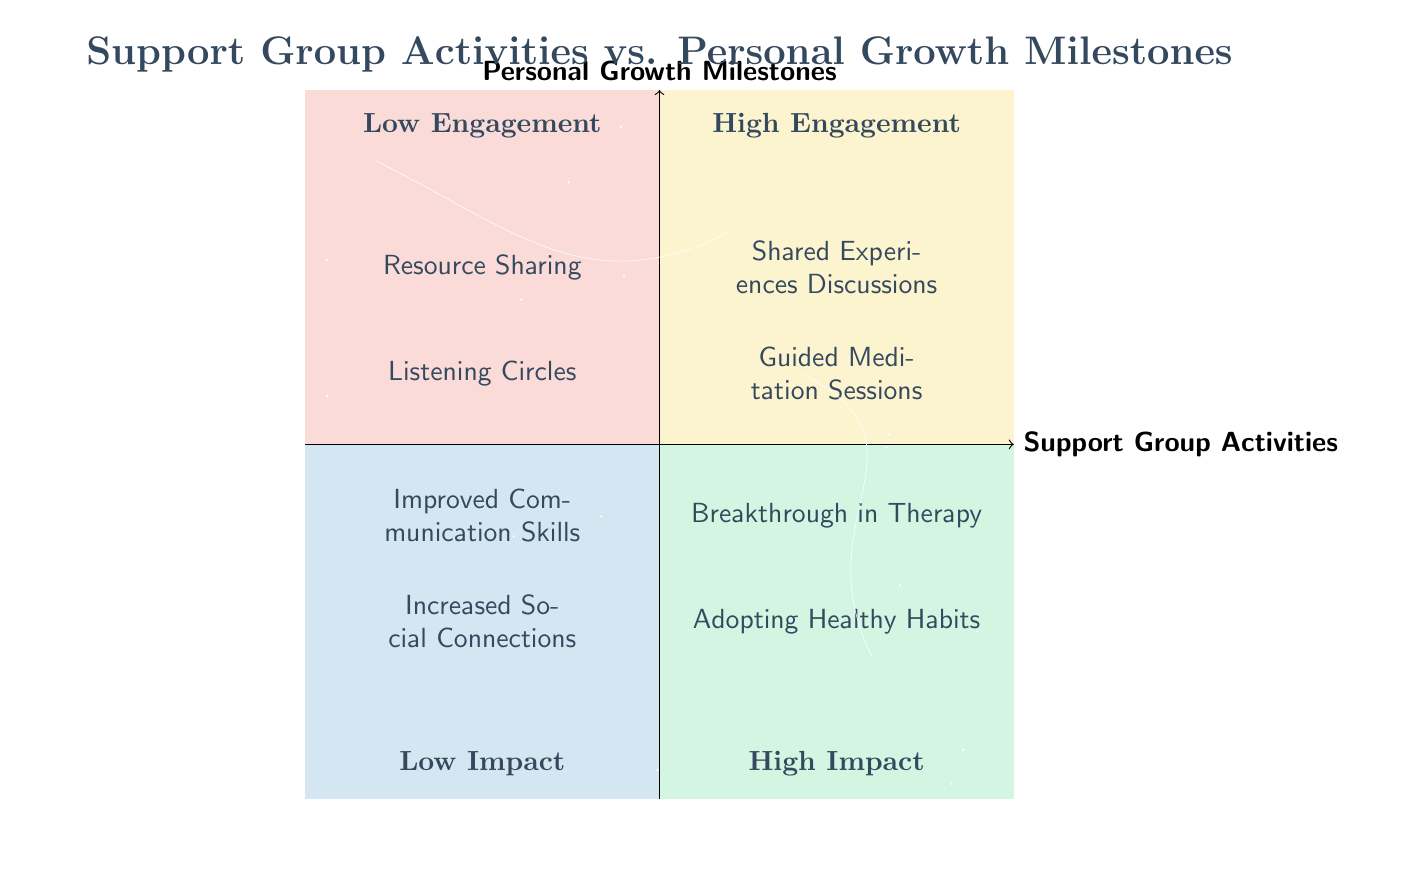What are the activities in the High Engagement quadrant? The High Engagement quadrant is found in the top right section of the diagram. In this section, there are two nodes, "Shared Experiences Discussions" and "Guided Meditation Sessions."
Answer: Shared Experiences Discussions, Guided Meditation Sessions Which Personal Growth Milestones are associated with Low Impact? The Low Impact section is located in the bottom left quadrant of the diagram. The two milestones listed there are "Improved Communication Skills" and "Increased Social Connections."
Answer: Improved Communication Skills, Increased Social Connections How many activities are categorized as Low Engagement? To find this, we look at the Low Engagement quadrant, which is in the bottom left portion of the diagram. There are two activities listed: "Resource Sharing" and "Listening Circles," which totals to two activities.
Answer: 2 What is the relationship between High Impact milestones and High Engagement activities? High Impact milestones, found in the top right quadrant, are "Breakthrough in Therapy" and "Adopting Healthy Habits." Both are associated with activities in the High Engagement quadrant. This suggests a positive correlation between engaging activities and significant personal growth outcomes.
Answer: Positive correlation Which activity is closest to the Low Impact milestones? In the diagram, the Low Impact milestones are located in the bottom left quadrant. The activity closest to this area, directly above it in the Low Engagement quadrant, is "Listening Circles."
Answer: Listening Circles How many nodes are in the Low Engagement quadrant? The Low Engagement quadrant contains two activities: "Resource Sharing" and "Listening Circles." By counting these, we can determine the total number of nodes present in this quadrant.
Answer: 2 What is typically the focus of Guided Meditation Sessions? Guided Meditation Sessions are listed in the High Engagement quadrant. These sessions focus on mindfulness activities which involve participating in meditation guided by a facilitator.
Answer: Mindfulness activities Which activity has the highest potential for impact according to the chart? To determine the activity with the highest potential for impact, we refer to the High Impact quadrant. The noted activities in this section are "Breakthrough in Therapy" and "Adopting Healthy Habits," with both considered significant.
Answer: Breakthrough in Therapy, Adopting Healthy Habits What is the term used for the type of sharing in the Resource Sharing activity? The Resource Sharing activity focuses on the sharing of articles, books, or videos related to personal growth. The term that captures this type of sharing is 'resource sharing.'
Answer: Resource sharing 